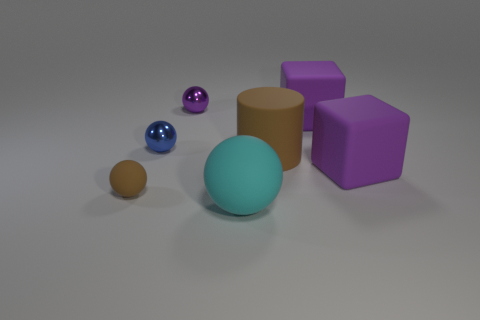Subtract all brown balls. How many balls are left? 3 Subtract 1 cubes. How many cubes are left? 1 Subtract all brown spheres. How many spheres are left? 3 Add 1 small matte spheres. How many objects exist? 8 Subtract 0 yellow balls. How many objects are left? 7 Subtract all cylinders. How many objects are left? 6 Subtract all cyan spheres. Subtract all purple cylinders. How many spheres are left? 3 Subtract all gray cubes. How many cyan spheres are left? 1 Subtract all green metallic balls. Subtract all tiny things. How many objects are left? 4 Add 6 brown objects. How many brown objects are left? 8 